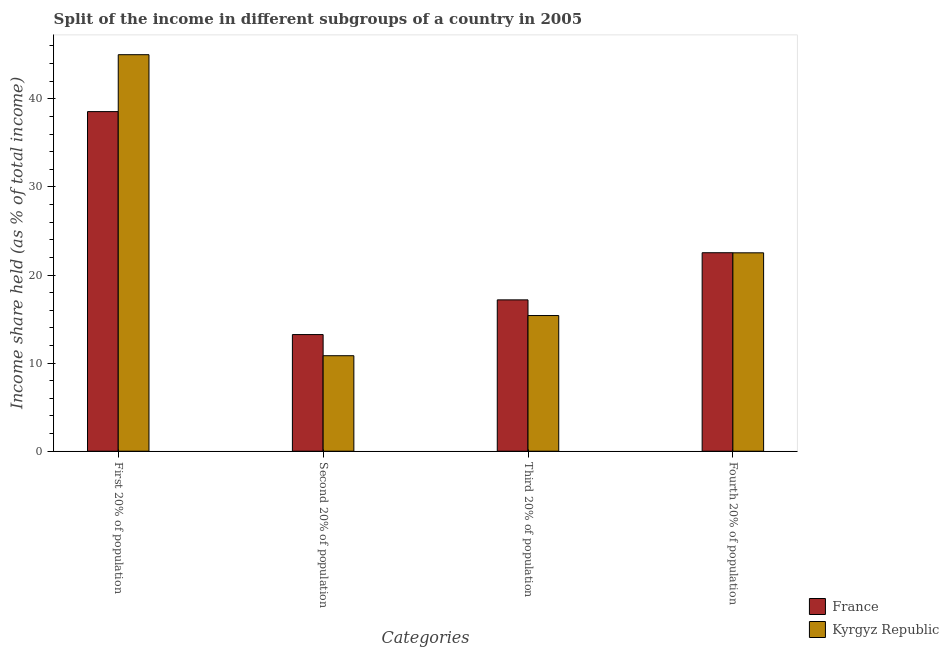Are the number of bars per tick equal to the number of legend labels?
Provide a short and direct response. Yes. What is the label of the 4th group of bars from the left?
Your answer should be compact. Fourth 20% of population. What is the share of the income held by second 20% of the population in France?
Offer a terse response. 13.24. Across all countries, what is the maximum share of the income held by third 20% of the population?
Your answer should be compact. 17.18. In which country was the share of the income held by third 20% of the population minimum?
Your answer should be compact. Kyrgyz Republic. What is the total share of the income held by third 20% of the population in the graph?
Your answer should be very brief. 32.58. What is the difference between the share of the income held by second 20% of the population in France and that in Kyrgyz Republic?
Provide a succinct answer. 2.4. What is the difference between the share of the income held by fourth 20% of the population in France and the share of the income held by second 20% of the population in Kyrgyz Republic?
Ensure brevity in your answer.  11.69. What is the average share of the income held by first 20% of the population per country?
Ensure brevity in your answer.  41.78. What is the difference between the share of the income held by first 20% of the population and share of the income held by third 20% of the population in Kyrgyz Republic?
Keep it short and to the point. 29.61. What is the ratio of the share of the income held by second 20% of the population in France to that in Kyrgyz Republic?
Your answer should be very brief. 1.22. Is the share of the income held by second 20% of the population in France less than that in Kyrgyz Republic?
Your response must be concise. No. Is the difference between the share of the income held by first 20% of the population in Kyrgyz Republic and France greater than the difference between the share of the income held by fourth 20% of the population in Kyrgyz Republic and France?
Provide a short and direct response. Yes. What is the difference between the highest and the second highest share of the income held by third 20% of the population?
Make the answer very short. 1.78. What is the difference between the highest and the lowest share of the income held by fourth 20% of the population?
Your answer should be very brief. 0.01. What does the 2nd bar from the left in First 20% of population represents?
Provide a short and direct response. Kyrgyz Republic. What does the 1st bar from the right in Third 20% of population represents?
Offer a terse response. Kyrgyz Republic. How many countries are there in the graph?
Your response must be concise. 2. Are the values on the major ticks of Y-axis written in scientific E-notation?
Give a very brief answer. No. Does the graph contain any zero values?
Offer a very short reply. No. Where does the legend appear in the graph?
Your response must be concise. Bottom right. What is the title of the graph?
Ensure brevity in your answer.  Split of the income in different subgroups of a country in 2005. Does "Somalia" appear as one of the legend labels in the graph?
Your response must be concise. No. What is the label or title of the X-axis?
Keep it short and to the point. Categories. What is the label or title of the Y-axis?
Keep it short and to the point. Income share held (as % of total income). What is the Income share held (as % of total income) of France in First 20% of population?
Keep it short and to the point. 38.55. What is the Income share held (as % of total income) in Kyrgyz Republic in First 20% of population?
Give a very brief answer. 45.01. What is the Income share held (as % of total income) in France in Second 20% of population?
Ensure brevity in your answer.  13.24. What is the Income share held (as % of total income) of Kyrgyz Republic in Second 20% of population?
Keep it short and to the point. 10.84. What is the Income share held (as % of total income) in France in Third 20% of population?
Provide a succinct answer. 17.18. What is the Income share held (as % of total income) in France in Fourth 20% of population?
Give a very brief answer. 22.53. What is the Income share held (as % of total income) of Kyrgyz Republic in Fourth 20% of population?
Make the answer very short. 22.52. Across all Categories, what is the maximum Income share held (as % of total income) in France?
Offer a very short reply. 38.55. Across all Categories, what is the maximum Income share held (as % of total income) in Kyrgyz Republic?
Provide a succinct answer. 45.01. Across all Categories, what is the minimum Income share held (as % of total income) of France?
Your answer should be compact. 13.24. Across all Categories, what is the minimum Income share held (as % of total income) in Kyrgyz Republic?
Offer a terse response. 10.84. What is the total Income share held (as % of total income) of France in the graph?
Ensure brevity in your answer.  91.5. What is the total Income share held (as % of total income) of Kyrgyz Republic in the graph?
Keep it short and to the point. 93.77. What is the difference between the Income share held (as % of total income) in France in First 20% of population and that in Second 20% of population?
Keep it short and to the point. 25.31. What is the difference between the Income share held (as % of total income) in Kyrgyz Republic in First 20% of population and that in Second 20% of population?
Keep it short and to the point. 34.17. What is the difference between the Income share held (as % of total income) of France in First 20% of population and that in Third 20% of population?
Ensure brevity in your answer.  21.37. What is the difference between the Income share held (as % of total income) of Kyrgyz Republic in First 20% of population and that in Third 20% of population?
Make the answer very short. 29.61. What is the difference between the Income share held (as % of total income) in France in First 20% of population and that in Fourth 20% of population?
Your answer should be very brief. 16.02. What is the difference between the Income share held (as % of total income) in Kyrgyz Republic in First 20% of population and that in Fourth 20% of population?
Provide a short and direct response. 22.49. What is the difference between the Income share held (as % of total income) in France in Second 20% of population and that in Third 20% of population?
Your answer should be compact. -3.94. What is the difference between the Income share held (as % of total income) of Kyrgyz Republic in Second 20% of population and that in Third 20% of population?
Give a very brief answer. -4.56. What is the difference between the Income share held (as % of total income) in France in Second 20% of population and that in Fourth 20% of population?
Your answer should be compact. -9.29. What is the difference between the Income share held (as % of total income) in Kyrgyz Republic in Second 20% of population and that in Fourth 20% of population?
Provide a short and direct response. -11.68. What is the difference between the Income share held (as % of total income) in France in Third 20% of population and that in Fourth 20% of population?
Make the answer very short. -5.35. What is the difference between the Income share held (as % of total income) in Kyrgyz Republic in Third 20% of population and that in Fourth 20% of population?
Your answer should be very brief. -7.12. What is the difference between the Income share held (as % of total income) of France in First 20% of population and the Income share held (as % of total income) of Kyrgyz Republic in Second 20% of population?
Offer a terse response. 27.71. What is the difference between the Income share held (as % of total income) of France in First 20% of population and the Income share held (as % of total income) of Kyrgyz Republic in Third 20% of population?
Offer a very short reply. 23.15. What is the difference between the Income share held (as % of total income) of France in First 20% of population and the Income share held (as % of total income) of Kyrgyz Republic in Fourth 20% of population?
Give a very brief answer. 16.03. What is the difference between the Income share held (as % of total income) of France in Second 20% of population and the Income share held (as % of total income) of Kyrgyz Republic in Third 20% of population?
Your answer should be compact. -2.16. What is the difference between the Income share held (as % of total income) of France in Second 20% of population and the Income share held (as % of total income) of Kyrgyz Republic in Fourth 20% of population?
Provide a short and direct response. -9.28. What is the difference between the Income share held (as % of total income) in France in Third 20% of population and the Income share held (as % of total income) in Kyrgyz Republic in Fourth 20% of population?
Provide a succinct answer. -5.34. What is the average Income share held (as % of total income) of France per Categories?
Offer a very short reply. 22.88. What is the average Income share held (as % of total income) in Kyrgyz Republic per Categories?
Provide a short and direct response. 23.44. What is the difference between the Income share held (as % of total income) in France and Income share held (as % of total income) in Kyrgyz Republic in First 20% of population?
Your answer should be very brief. -6.46. What is the difference between the Income share held (as % of total income) of France and Income share held (as % of total income) of Kyrgyz Republic in Third 20% of population?
Your answer should be very brief. 1.78. What is the ratio of the Income share held (as % of total income) in France in First 20% of population to that in Second 20% of population?
Your answer should be compact. 2.91. What is the ratio of the Income share held (as % of total income) in Kyrgyz Republic in First 20% of population to that in Second 20% of population?
Offer a terse response. 4.15. What is the ratio of the Income share held (as % of total income) in France in First 20% of population to that in Third 20% of population?
Your answer should be very brief. 2.24. What is the ratio of the Income share held (as % of total income) of Kyrgyz Republic in First 20% of population to that in Third 20% of population?
Your response must be concise. 2.92. What is the ratio of the Income share held (as % of total income) in France in First 20% of population to that in Fourth 20% of population?
Offer a very short reply. 1.71. What is the ratio of the Income share held (as % of total income) of Kyrgyz Republic in First 20% of population to that in Fourth 20% of population?
Give a very brief answer. 2. What is the ratio of the Income share held (as % of total income) of France in Second 20% of population to that in Third 20% of population?
Your answer should be very brief. 0.77. What is the ratio of the Income share held (as % of total income) of Kyrgyz Republic in Second 20% of population to that in Third 20% of population?
Provide a succinct answer. 0.7. What is the ratio of the Income share held (as % of total income) in France in Second 20% of population to that in Fourth 20% of population?
Your answer should be compact. 0.59. What is the ratio of the Income share held (as % of total income) of Kyrgyz Republic in Second 20% of population to that in Fourth 20% of population?
Provide a short and direct response. 0.48. What is the ratio of the Income share held (as % of total income) in France in Third 20% of population to that in Fourth 20% of population?
Ensure brevity in your answer.  0.76. What is the ratio of the Income share held (as % of total income) of Kyrgyz Republic in Third 20% of population to that in Fourth 20% of population?
Your response must be concise. 0.68. What is the difference between the highest and the second highest Income share held (as % of total income) in France?
Offer a terse response. 16.02. What is the difference between the highest and the second highest Income share held (as % of total income) of Kyrgyz Republic?
Offer a terse response. 22.49. What is the difference between the highest and the lowest Income share held (as % of total income) in France?
Keep it short and to the point. 25.31. What is the difference between the highest and the lowest Income share held (as % of total income) in Kyrgyz Republic?
Your answer should be compact. 34.17. 